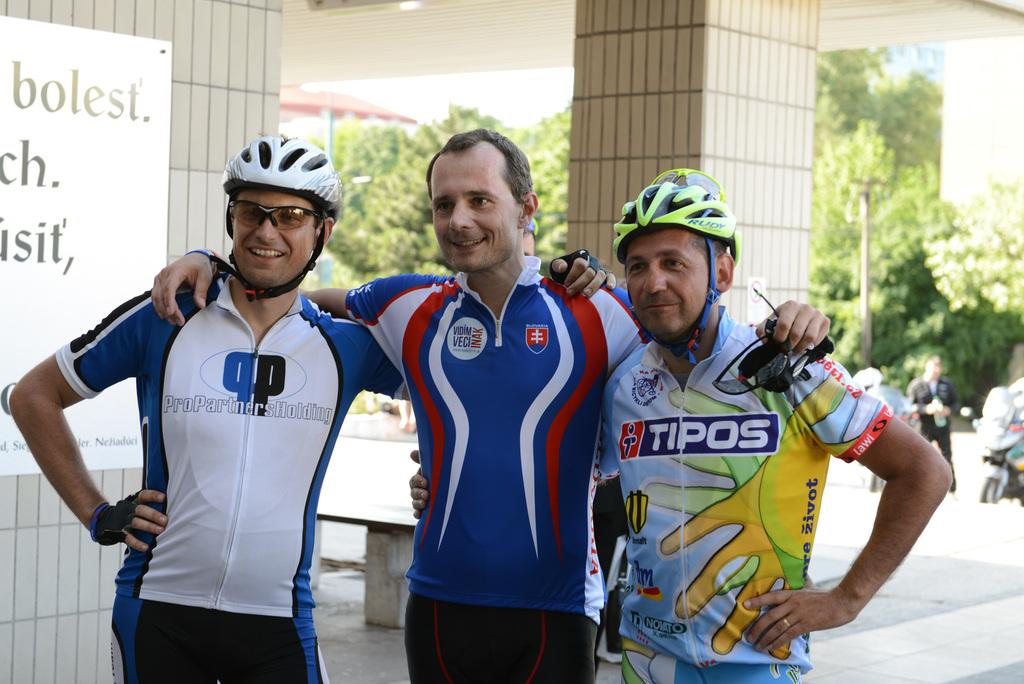<image>
Present a compact description of the photo's key features. Three men posing with one wearing a Tipos emblazoned shirt. 